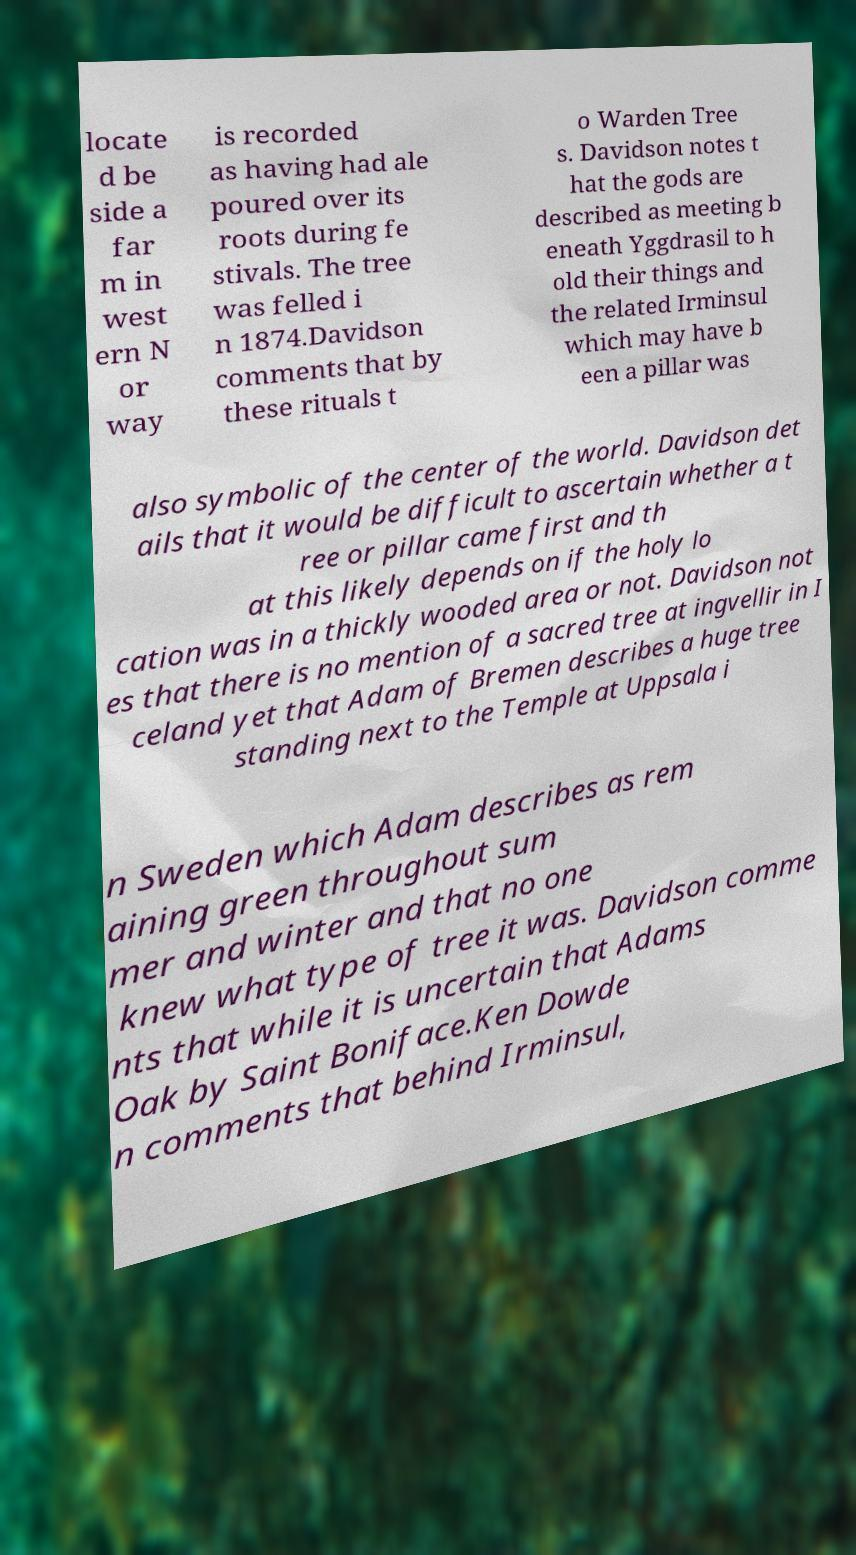There's text embedded in this image that I need extracted. Can you transcribe it verbatim? locate d be side a far m in west ern N or way is recorded as having had ale poured over its roots during fe stivals. The tree was felled i n 1874.Davidson comments that by these rituals t o Warden Tree s. Davidson notes t hat the gods are described as meeting b eneath Yggdrasil to h old their things and the related Irminsul which may have b een a pillar was also symbolic of the center of the world. Davidson det ails that it would be difficult to ascertain whether a t ree or pillar came first and th at this likely depends on if the holy lo cation was in a thickly wooded area or not. Davidson not es that there is no mention of a sacred tree at ingvellir in I celand yet that Adam of Bremen describes a huge tree standing next to the Temple at Uppsala i n Sweden which Adam describes as rem aining green throughout sum mer and winter and that no one knew what type of tree it was. Davidson comme nts that while it is uncertain that Adams Oak by Saint Boniface.Ken Dowde n comments that behind Irminsul, 